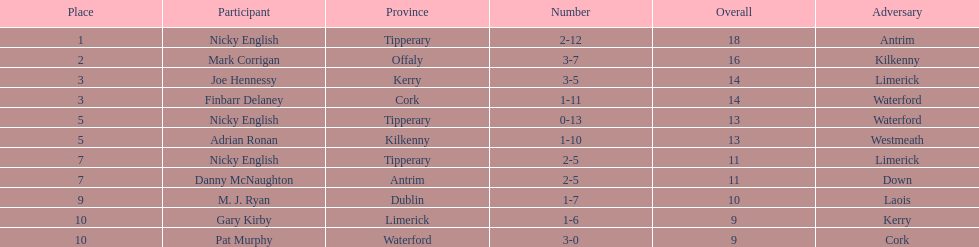Which player ranked the most? Nicky English. 